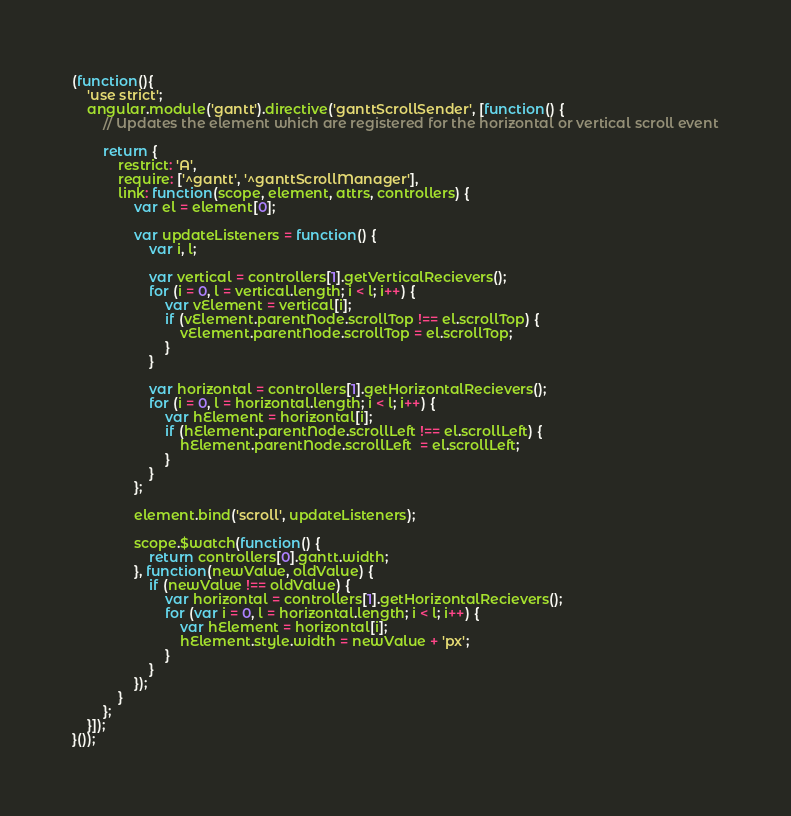<code> <loc_0><loc_0><loc_500><loc_500><_JavaScript_>(function(){
    'use strict';
    angular.module('gantt').directive('ganttScrollSender', [function() {
        // Updates the element which are registered for the horizontal or vertical scroll event

        return {
            restrict: 'A',
            require: ['^gantt', '^ganttScrollManager'],
            link: function(scope, element, attrs, controllers) {
                var el = element[0];

                var updateListeners = function() {
                    var i, l;

                    var vertical = controllers[1].getVerticalRecievers();
                    for (i = 0, l = vertical.length; i < l; i++) {
                        var vElement = vertical[i];
                        if (vElement.parentNode.scrollTop !== el.scrollTop) {
                            vElement.parentNode.scrollTop = el.scrollTop;
                        }
                    }

                    var horizontal = controllers[1].getHorizontalRecievers();
                    for (i = 0, l = horizontal.length; i < l; i++) {
                        var hElement = horizontal[i];
                        if (hElement.parentNode.scrollLeft !== el.scrollLeft) {
                            hElement.parentNode.scrollLeft  = el.scrollLeft;
                        }
                    }
                };

                element.bind('scroll', updateListeners);

                scope.$watch(function() {
                    return controllers[0].gantt.width;
                }, function(newValue, oldValue) {
                    if (newValue !== oldValue) {
                        var horizontal = controllers[1].getHorizontalRecievers();
                        for (var i = 0, l = horizontal.length; i < l; i++) {
                            var hElement = horizontal[i];
                            hElement.style.width = newValue + 'px';
                        }
                    }
                });
            }
        };
    }]);
}());

</code> 